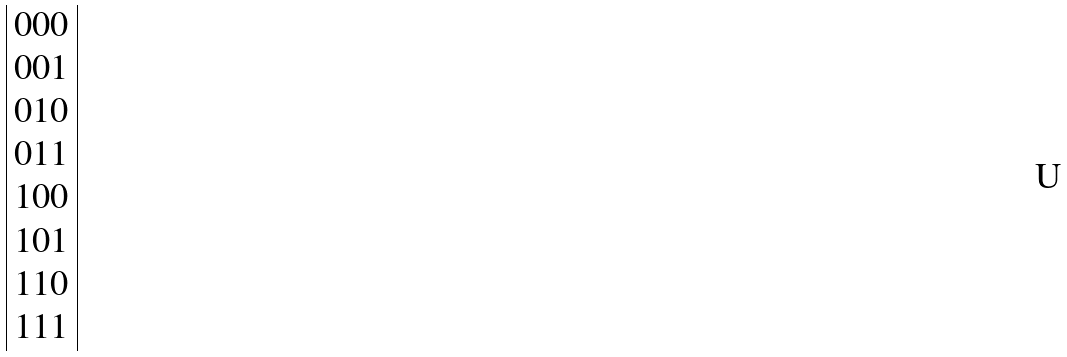<formula> <loc_0><loc_0><loc_500><loc_500>\begin{array} { | c | } 0 0 0 \\ 0 0 1 \\ 0 1 0 \\ 0 1 1 \\ 1 0 0 \\ 1 0 1 \\ 1 1 0 \\ 1 1 1 \\ \end{array}</formula> 